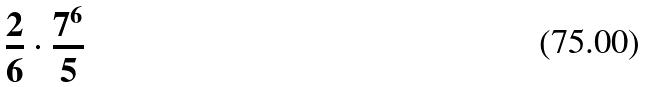Convert formula to latex. <formula><loc_0><loc_0><loc_500><loc_500>\frac { 2 } { 6 } \cdot \frac { 7 ^ { 6 } } { 5 }</formula> 